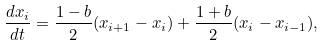Convert formula to latex. <formula><loc_0><loc_0><loc_500><loc_500>\frac { d x _ { i } } { d t } = \frac { 1 - b } { 2 } ( x _ { i + 1 } - x _ { i } ) + \frac { 1 + b } { 2 } ( x _ { i } - x _ { i - 1 } ) ,</formula> 